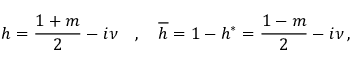<formula> <loc_0><loc_0><loc_500><loc_500>h = \frac { 1 + m } 2 - i \nu \quad , \quad \overline { h } = 1 - h ^ { * } = \frac { 1 - m } 2 - i \nu \, ,</formula> 